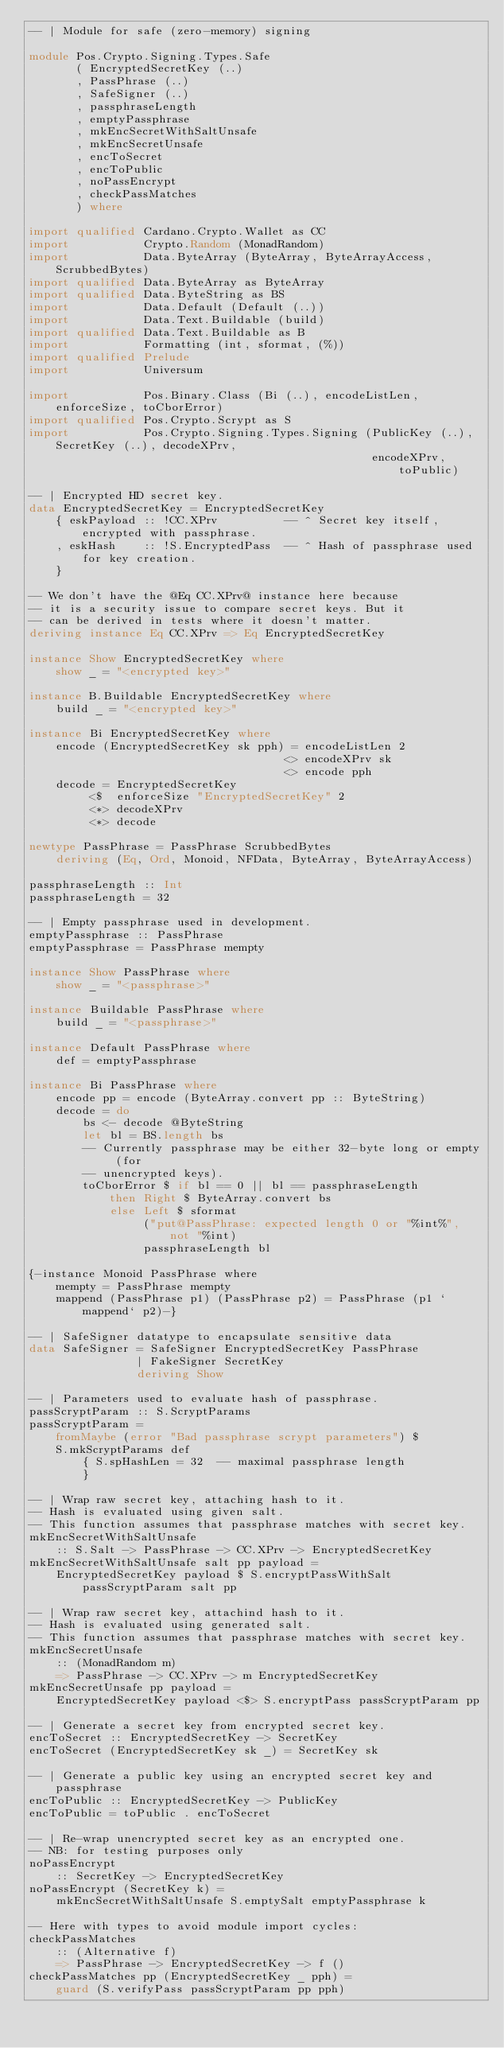<code> <loc_0><loc_0><loc_500><loc_500><_Haskell_>-- | Module for safe (zero-memory) signing

module Pos.Crypto.Signing.Types.Safe
       ( EncryptedSecretKey (..)
       , PassPhrase (..)
       , SafeSigner (..)
       , passphraseLength
       , emptyPassphrase
       , mkEncSecretWithSaltUnsafe
       , mkEncSecretUnsafe
       , encToSecret
       , encToPublic
       , noPassEncrypt
       , checkPassMatches
       ) where

import qualified Cardano.Crypto.Wallet as CC
import           Crypto.Random (MonadRandom)
import           Data.ByteArray (ByteArray, ByteArrayAccess, ScrubbedBytes)
import qualified Data.ByteArray as ByteArray
import qualified Data.ByteString as BS
import           Data.Default (Default (..))
import           Data.Text.Buildable (build)
import qualified Data.Text.Buildable as B
import           Formatting (int, sformat, (%))
import qualified Prelude
import           Universum

import           Pos.Binary.Class (Bi (..), encodeListLen, enforceSize, toCborError)
import qualified Pos.Crypto.Scrypt as S
import           Pos.Crypto.Signing.Types.Signing (PublicKey (..), SecretKey (..), decodeXPrv,
                                                   encodeXPrv, toPublic)

-- | Encrypted HD secret key.
data EncryptedSecretKey = EncryptedSecretKey
    { eskPayload :: !CC.XPrv          -- ^ Secret key itself, encrypted with passphrase.
    , eskHash    :: !S.EncryptedPass  -- ^ Hash of passphrase used for key creation.
    }

-- We don't have the @Eq CC.XPrv@ instance here because
-- it is a security issue to compare secret keys. But it
-- can be derived in tests where it doesn't matter.
deriving instance Eq CC.XPrv => Eq EncryptedSecretKey

instance Show EncryptedSecretKey where
    show _ = "<encrypted key>"

instance B.Buildable EncryptedSecretKey where
    build _ = "<encrypted key>"

instance Bi EncryptedSecretKey where
    encode (EncryptedSecretKey sk pph) = encodeListLen 2
                                      <> encodeXPrv sk
                                      <> encode pph
    decode = EncryptedSecretKey
         <$  enforceSize "EncryptedSecretKey" 2
         <*> decodeXPrv
         <*> decode

newtype PassPhrase = PassPhrase ScrubbedBytes
    deriving (Eq, Ord, Monoid, NFData, ByteArray, ByteArrayAccess)

passphraseLength :: Int
passphraseLength = 32

-- | Empty passphrase used in development.
emptyPassphrase :: PassPhrase
emptyPassphrase = PassPhrase mempty

instance Show PassPhrase where
    show _ = "<passphrase>"

instance Buildable PassPhrase where
    build _ = "<passphrase>"

instance Default PassPhrase where
    def = emptyPassphrase

instance Bi PassPhrase where
    encode pp = encode (ByteArray.convert pp :: ByteString)
    decode = do
        bs <- decode @ByteString
        let bl = BS.length bs
        -- Currently passphrase may be either 32-byte long or empty (for
        -- unencrypted keys).
        toCborError $ if bl == 0 || bl == passphraseLength
            then Right $ ByteArray.convert bs
            else Left $ sformat
                 ("put@PassPhrase: expected length 0 or "%int%", not "%int)
                 passphraseLength bl

{-instance Monoid PassPhrase where
    mempty = PassPhrase mempty
    mappend (PassPhrase p1) (PassPhrase p2) = PassPhrase (p1 `mappend` p2)-}

-- | SafeSigner datatype to encapsulate sensitive data
data SafeSigner = SafeSigner EncryptedSecretKey PassPhrase
                | FakeSigner SecretKey
                deriving Show

-- | Parameters used to evaluate hash of passphrase.
passScryptParam :: S.ScryptParams
passScryptParam =
    fromMaybe (error "Bad passphrase scrypt parameters") $
    S.mkScryptParams def
        { S.spHashLen = 32  -- maximal passphrase length
        }

-- | Wrap raw secret key, attaching hash to it.
-- Hash is evaluated using given salt.
-- This function assumes that passphrase matches with secret key.
mkEncSecretWithSaltUnsafe
    :: S.Salt -> PassPhrase -> CC.XPrv -> EncryptedSecretKey
mkEncSecretWithSaltUnsafe salt pp payload =
    EncryptedSecretKey payload $ S.encryptPassWithSalt passScryptParam salt pp

-- | Wrap raw secret key, attachind hash to it.
-- Hash is evaluated using generated salt.
-- This function assumes that passphrase matches with secret key.
mkEncSecretUnsafe
    :: (MonadRandom m)
    => PassPhrase -> CC.XPrv -> m EncryptedSecretKey
mkEncSecretUnsafe pp payload =
    EncryptedSecretKey payload <$> S.encryptPass passScryptParam pp

-- | Generate a secret key from encrypted secret key.
encToSecret :: EncryptedSecretKey -> SecretKey
encToSecret (EncryptedSecretKey sk _) = SecretKey sk

-- | Generate a public key using an encrypted secret key and passphrase
encToPublic :: EncryptedSecretKey -> PublicKey
encToPublic = toPublic . encToSecret

-- | Re-wrap unencrypted secret key as an encrypted one.
-- NB: for testing purposes only
noPassEncrypt
    :: SecretKey -> EncryptedSecretKey
noPassEncrypt (SecretKey k) =
    mkEncSecretWithSaltUnsafe S.emptySalt emptyPassphrase k

-- Here with types to avoid module import cycles:
checkPassMatches
    :: (Alternative f)
    => PassPhrase -> EncryptedSecretKey -> f ()
checkPassMatches pp (EncryptedSecretKey _ pph) =
    guard (S.verifyPass passScryptParam pp pph)
</code> 